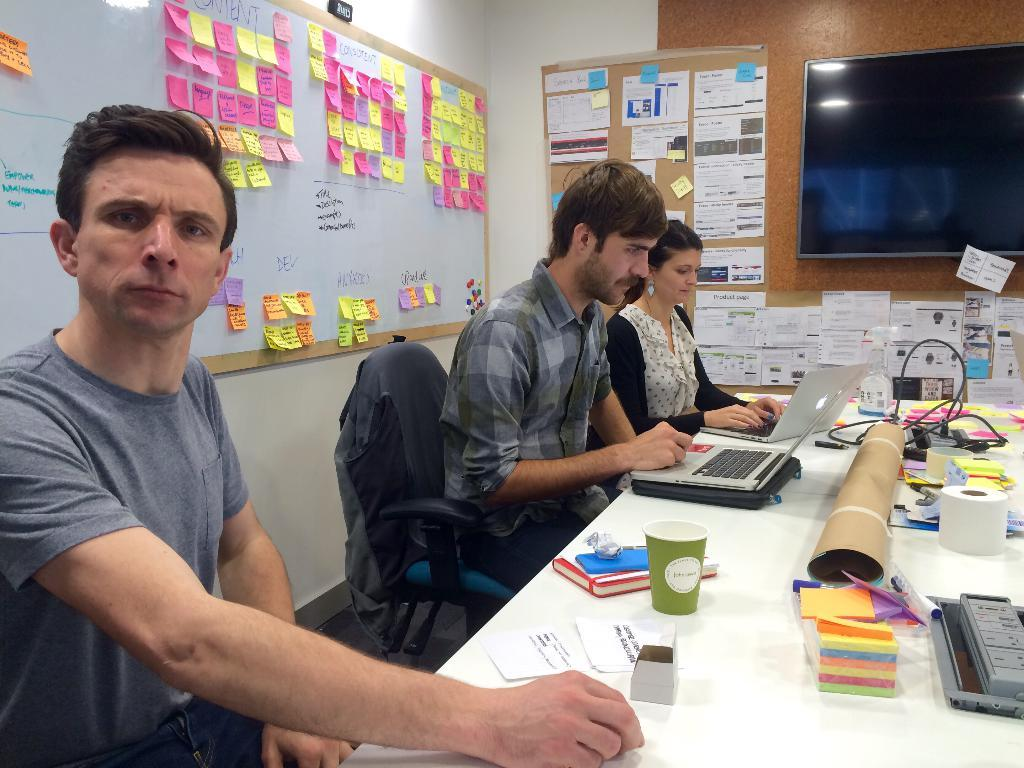How many people are sitting in the image? There are three people sitting on chairs in the image. What can be seen on the wall in the image? The wall is white in color in the image. What is present on the table in the image? There are papers, books, laptops, and a wire on the table in the image. What else is visible in the image besides the people and the table? There is a screen and posters in the image. What type of glue is being used to stick the note on the pocket in the image? There is no note, glue, or pocket present in the image. 